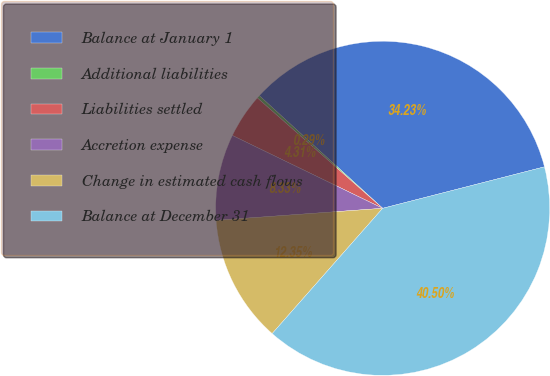Convert chart. <chart><loc_0><loc_0><loc_500><loc_500><pie_chart><fcel>Balance at January 1<fcel>Additional liabilities<fcel>Liabilities settled<fcel>Accretion expense<fcel>Change in estimated cash flows<fcel>Balance at December 31<nl><fcel>34.23%<fcel>0.29%<fcel>4.31%<fcel>8.33%<fcel>12.35%<fcel>40.5%<nl></chart> 